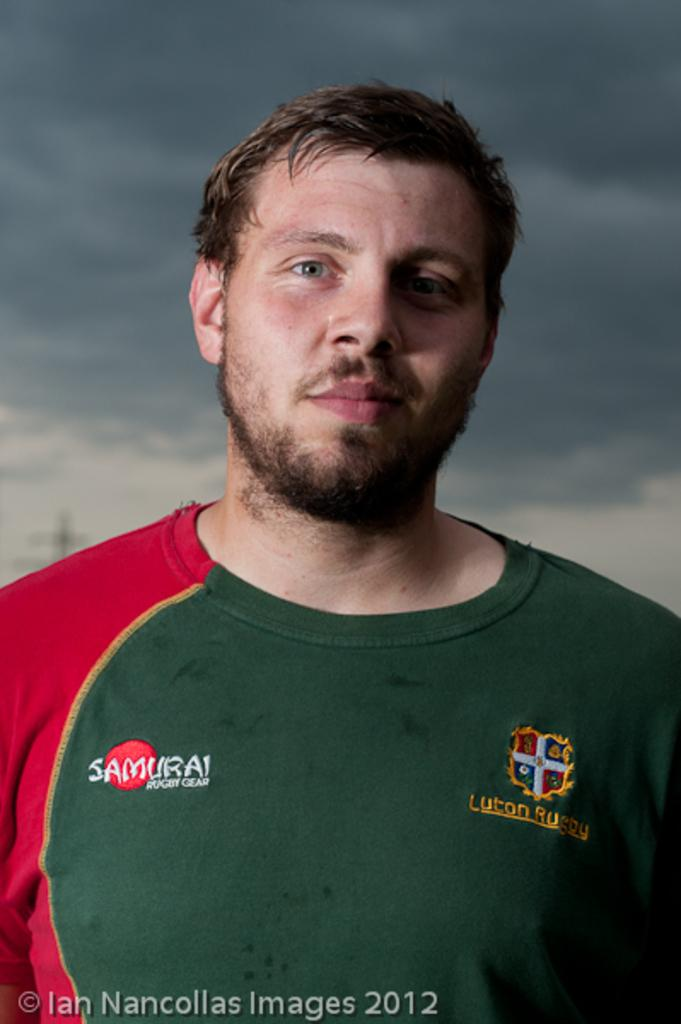Who or what is in the front of the image? There is a person in the front of the image. What can be seen in the background of the image? There is a cloudy sky in the background of the image. Is there any text or marking at the bottom of the image? Yes, there is a watermark at the bottom of the image. How many eggs are visible in the image? There are no eggs present in the image. What type of tool is being used by the person in the image? The image does not show the person using any tool, such as a wrench. 